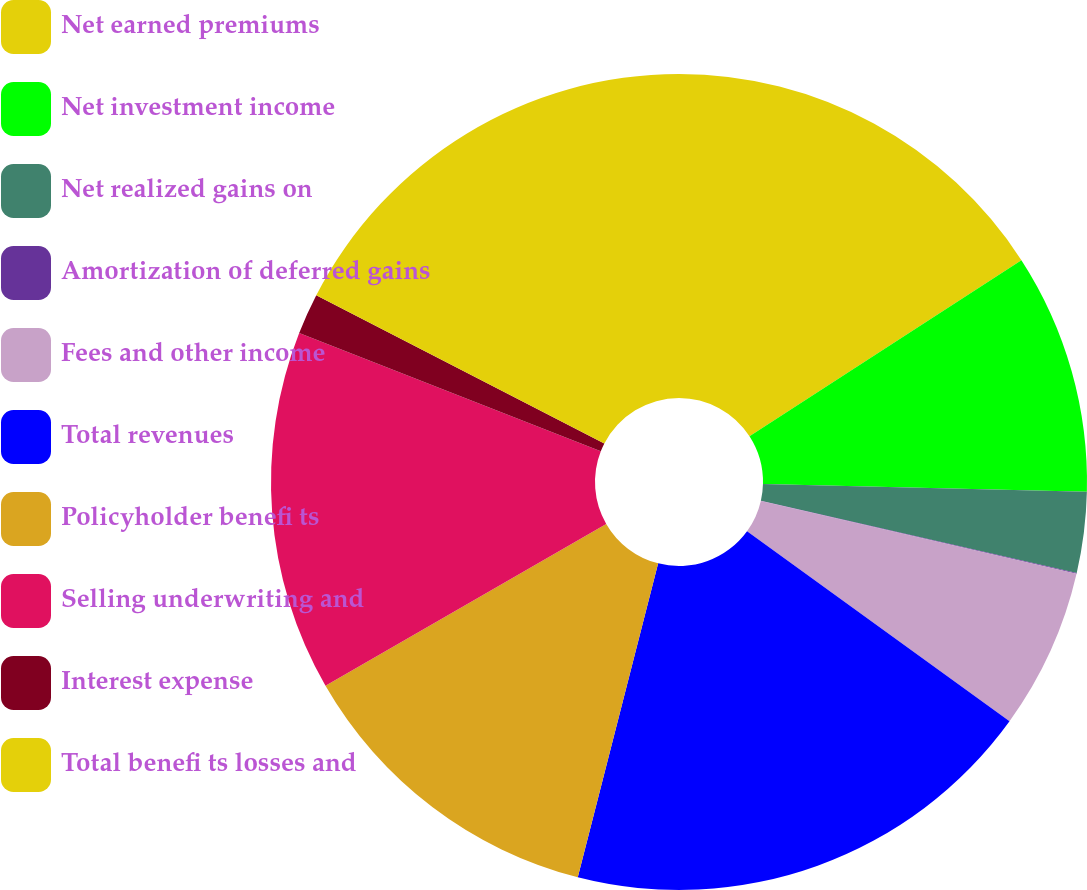<chart> <loc_0><loc_0><loc_500><loc_500><pie_chart><fcel>Net earned premiums<fcel>Net investment income<fcel>Net realized gains on<fcel>Amortization of deferred gains<fcel>Fees and other income<fcel>Total revenues<fcel>Policyholder benefi ts<fcel>Selling underwriting and<fcel>Interest expense<fcel>Total benefi ts losses and<nl><fcel>15.85%<fcel>9.53%<fcel>3.2%<fcel>0.03%<fcel>6.36%<fcel>19.02%<fcel>12.69%<fcel>14.27%<fcel>1.62%<fcel>17.43%<nl></chart> 